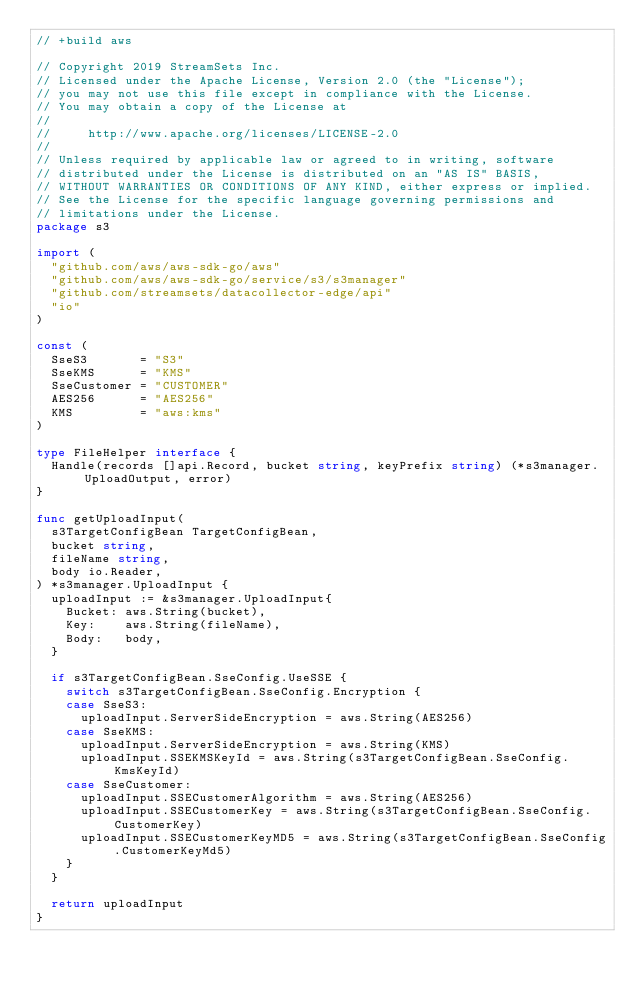<code> <loc_0><loc_0><loc_500><loc_500><_Go_>// +build aws

// Copyright 2019 StreamSets Inc.
// Licensed under the Apache License, Version 2.0 (the "License");
// you may not use this file except in compliance with the License.
// You may obtain a copy of the License at
//
//     http://www.apache.org/licenses/LICENSE-2.0
//
// Unless required by applicable law or agreed to in writing, software
// distributed under the License is distributed on an "AS IS" BASIS,
// WITHOUT WARRANTIES OR CONDITIONS OF ANY KIND, either express or implied.
// See the License for the specific language governing permissions and
// limitations under the License.
package s3

import (
	"github.com/aws/aws-sdk-go/aws"
	"github.com/aws/aws-sdk-go/service/s3/s3manager"
	"github.com/streamsets/datacollector-edge/api"
	"io"
)

const (
	SseS3       = "S3"
	SseKMS      = "KMS"
	SseCustomer = "CUSTOMER"
	AES256      = "AES256"
	KMS         = "aws:kms"
)

type FileHelper interface {
	Handle(records []api.Record, bucket string, keyPrefix string) (*s3manager.UploadOutput, error)
}

func getUploadInput(
	s3TargetConfigBean TargetConfigBean,
	bucket string,
	fileName string,
	body io.Reader,
) *s3manager.UploadInput {
	uploadInput := &s3manager.UploadInput{
		Bucket: aws.String(bucket),
		Key:    aws.String(fileName),
		Body:   body,
	}

	if s3TargetConfigBean.SseConfig.UseSSE {
		switch s3TargetConfigBean.SseConfig.Encryption {
		case SseS3:
			uploadInput.ServerSideEncryption = aws.String(AES256)
		case SseKMS:
			uploadInput.ServerSideEncryption = aws.String(KMS)
			uploadInput.SSEKMSKeyId = aws.String(s3TargetConfigBean.SseConfig.KmsKeyId)
		case SseCustomer:
			uploadInput.SSECustomerAlgorithm = aws.String(AES256)
			uploadInput.SSECustomerKey = aws.String(s3TargetConfigBean.SseConfig.CustomerKey)
			uploadInput.SSECustomerKeyMD5 = aws.String(s3TargetConfigBean.SseConfig.CustomerKeyMd5)
		}
	}

	return uploadInput
}
</code> 